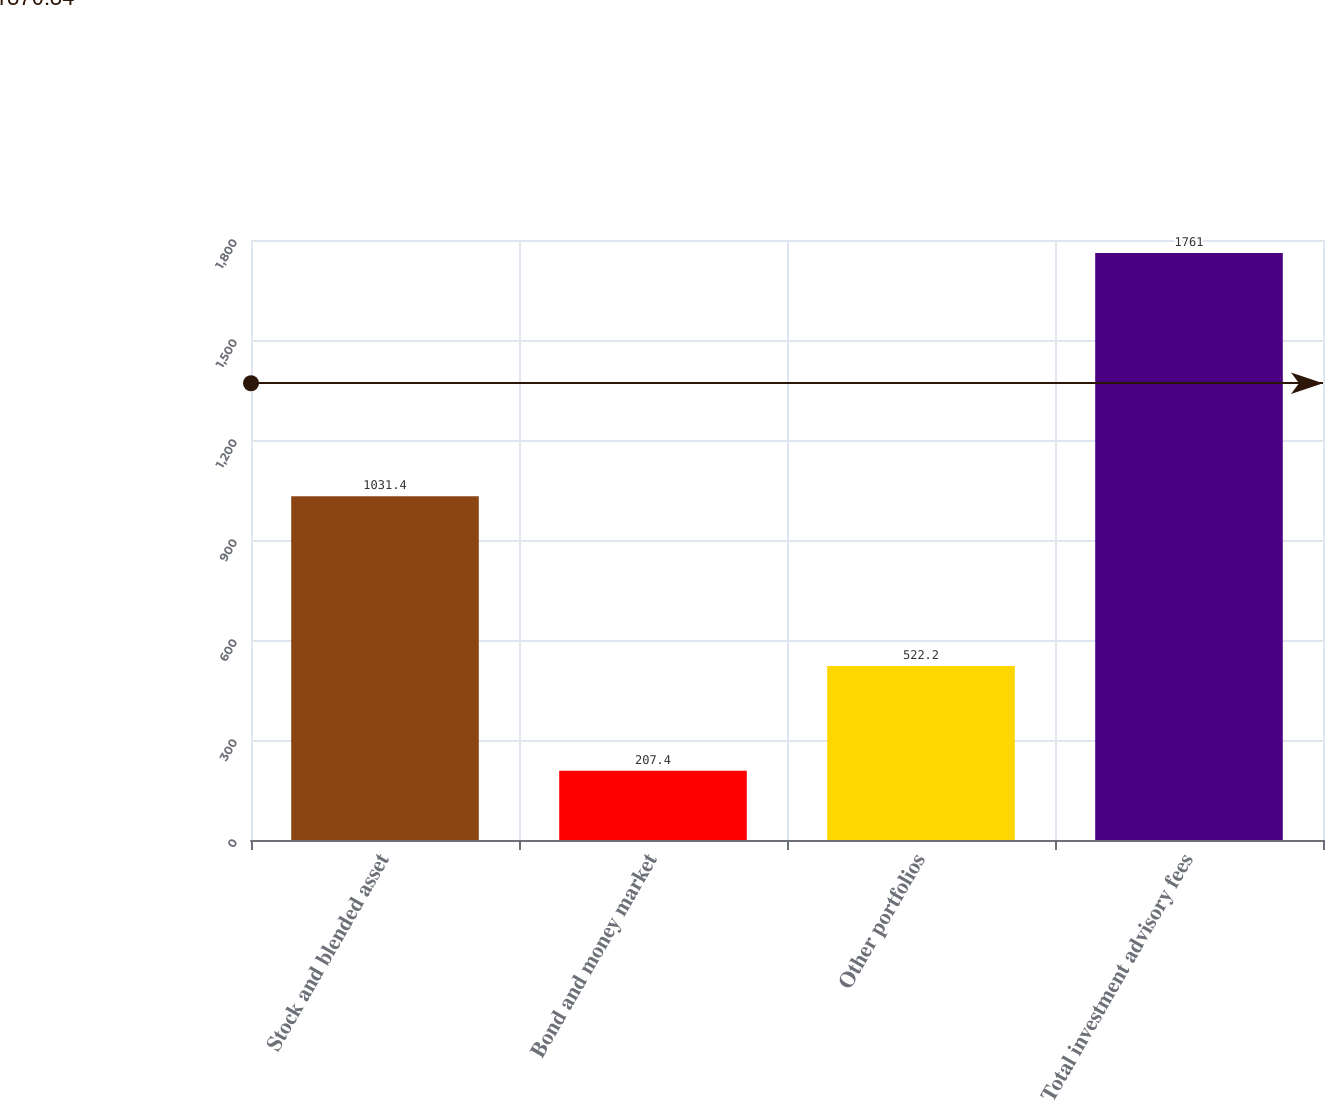<chart> <loc_0><loc_0><loc_500><loc_500><bar_chart><fcel>Stock and blended asset<fcel>Bond and money market<fcel>Other portfolios<fcel>Total investment advisory fees<nl><fcel>1031.4<fcel>207.4<fcel>522.2<fcel>1761<nl></chart> 